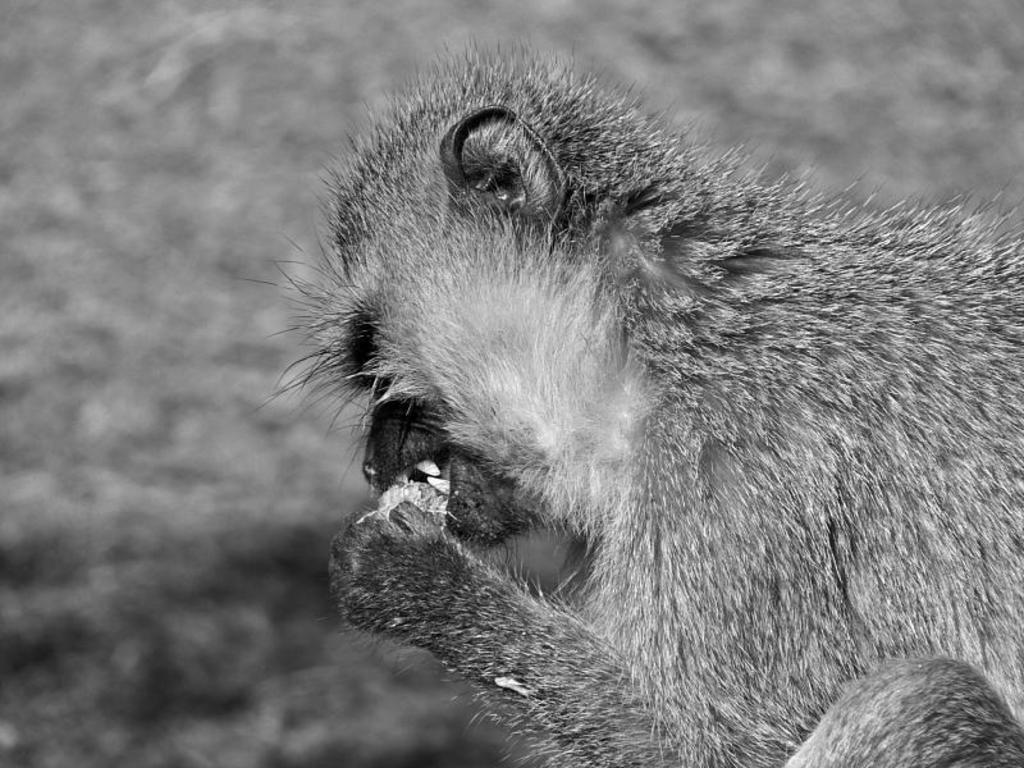What animal is present in the image? There is a monkey in the picture. What is the monkey doing in the image? The monkey is eating something. Can you describe the object being eaten by the monkey? The object being eaten appears to be soothing. What type of brick is the stranger holding in the image? There is no stranger or brick present in the image; it features a monkey eating something. What is the butter used for in the image? There is no butter present in the image. 